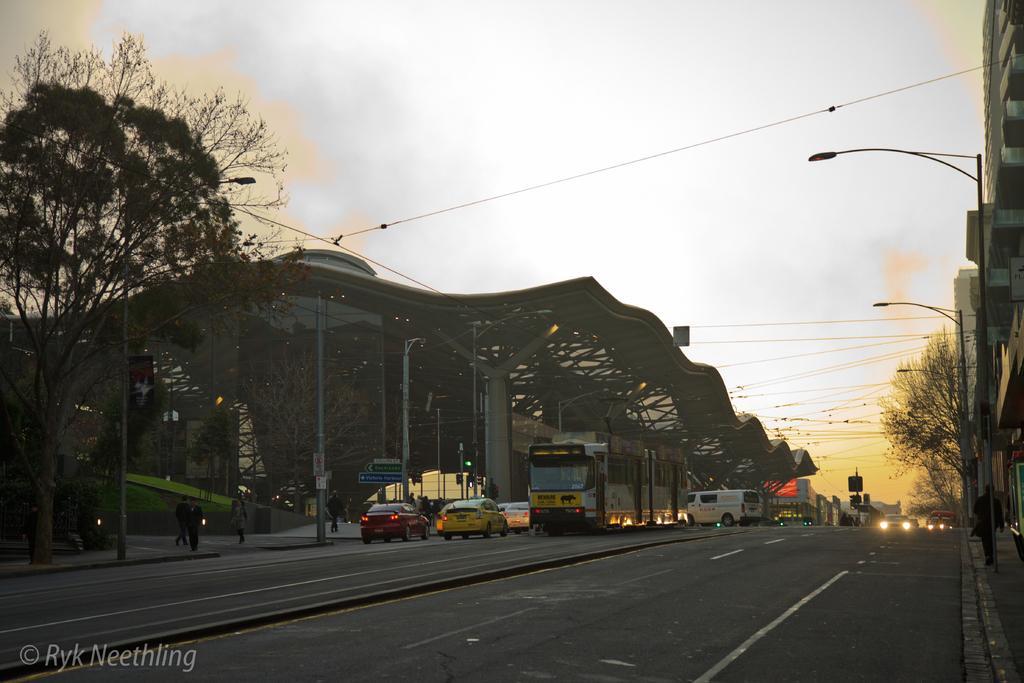Could you give a brief overview of what you see in this image? In the center of the image we can a shed, trees, cars, buses, light, electric pole, building, some persons are there. At the top of the image sky is present. At the bottom of the image road is there. 